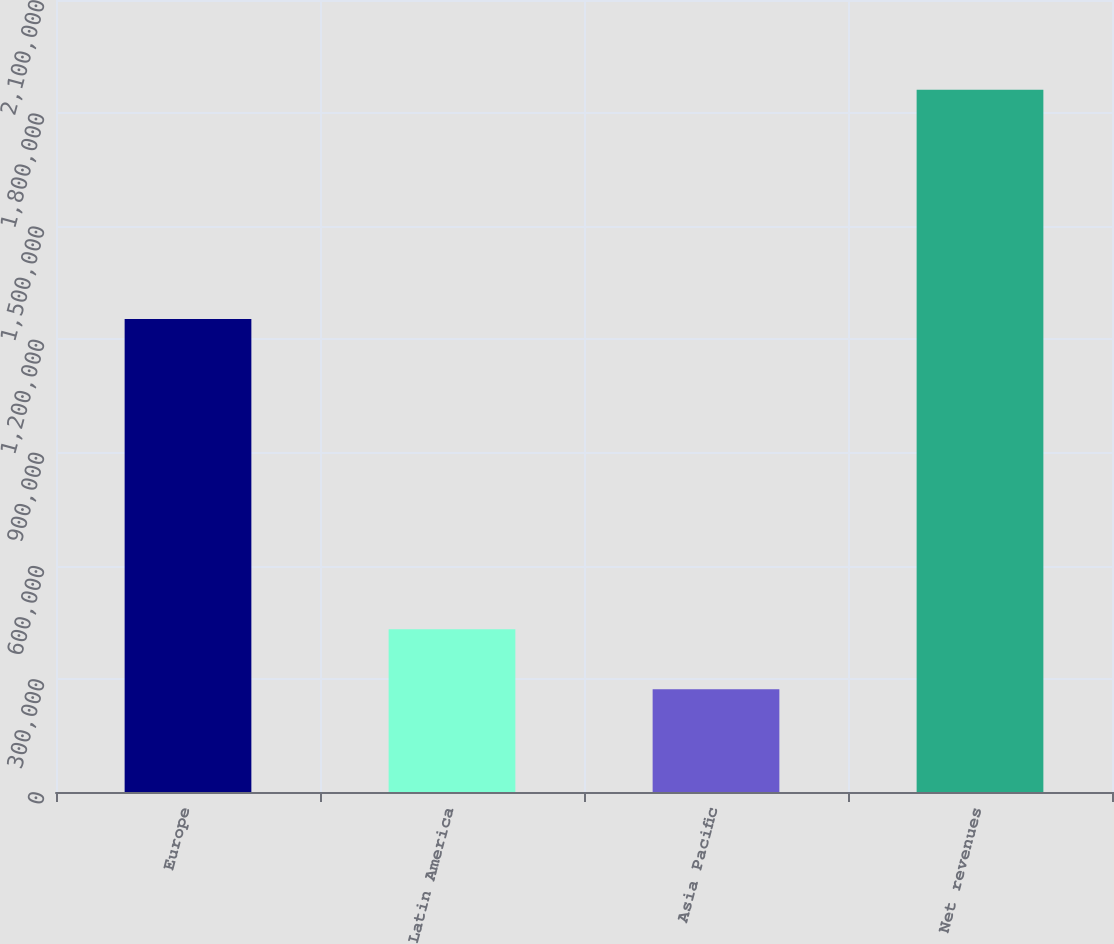Convert chart to OTSL. <chart><loc_0><loc_0><loc_500><loc_500><bar_chart><fcel>Europe<fcel>Latin America<fcel>Asia Pacific<fcel>Net revenues<nl><fcel>1.25443e+06<fcel>431518<fcel>272587<fcel>1.8619e+06<nl></chart> 